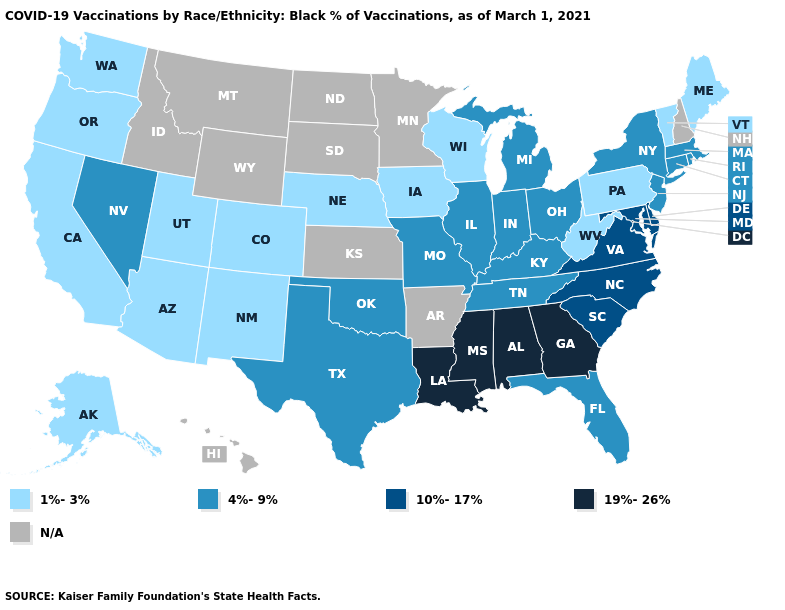Which states have the lowest value in the USA?
Answer briefly. Alaska, Arizona, California, Colorado, Iowa, Maine, Nebraska, New Mexico, Oregon, Pennsylvania, Utah, Vermont, Washington, West Virginia, Wisconsin. What is the lowest value in the USA?
Give a very brief answer. 1%-3%. Which states hav the highest value in the West?
Short answer required. Nevada. Does the first symbol in the legend represent the smallest category?
Be succinct. Yes. Name the states that have a value in the range N/A?
Give a very brief answer. Arkansas, Hawaii, Idaho, Kansas, Minnesota, Montana, New Hampshire, North Dakota, South Dakota, Wyoming. Among the states that border Arizona , which have the lowest value?
Give a very brief answer. California, Colorado, New Mexico, Utah. Name the states that have a value in the range 19%-26%?
Write a very short answer. Alabama, Georgia, Louisiana, Mississippi. Is the legend a continuous bar?
Answer briefly. No. Name the states that have a value in the range 19%-26%?
Short answer required. Alabama, Georgia, Louisiana, Mississippi. Name the states that have a value in the range 1%-3%?
Short answer required. Alaska, Arizona, California, Colorado, Iowa, Maine, Nebraska, New Mexico, Oregon, Pennsylvania, Utah, Vermont, Washington, West Virginia, Wisconsin. Name the states that have a value in the range 4%-9%?
Keep it brief. Connecticut, Florida, Illinois, Indiana, Kentucky, Massachusetts, Michigan, Missouri, Nevada, New Jersey, New York, Ohio, Oklahoma, Rhode Island, Tennessee, Texas. Which states have the lowest value in the MidWest?
Write a very short answer. Iowa, Nebraska, Wisconsin. What is the value of Wisconsin?
Concise answer only. 1%-3%. 